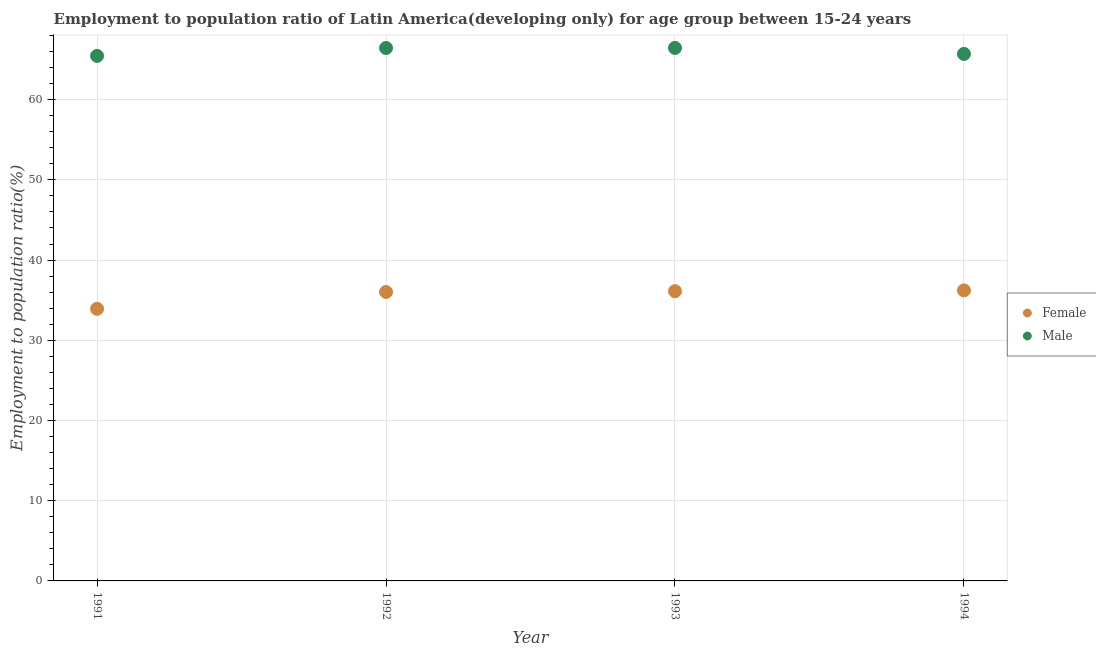How many different coloured dotlines are there?
Offer a terse response. 2. What is the employment to population ratio(male) in 1994?
Offer a very short reply. 65.7. Across all years, what is the maximum employment to population ratio(male)?
Provide a succinct answer. 66.45. Across all years, what is the minimum employment to population ratio(male)?
Keep it short and to the point. 65.45. In which year was the employment to population ratio(female) minimum?
Your answer should be compact. 1991. What is the total employment to population ratio(male) in the graph?
Offer a terse response. 264.04. What is the difference between the employment to population ratio(male) in 1992 and that in 1993?
Provide a succinct answer. -0.01. What is the difference between the employment to population ratio(male) in 1994 and the employment to population ratio(female) in 1992?
Provide a short and direct response. 29.68. What is the average employment to population ratio(female) per year?
Ensure brevity in your answer.  35.57. In the year 1994, what is the difference between the employment to population ratio(male) and employment to population ratio(female)?
Ensure brevity in your answer.  29.48. In how many years, is the employment to population ratio(female) greater than 4 %?
Provide a short and direct response. 4. What is the ratio of the employment to population ratio(male) in 1992 to that in 1994?
Ensure brevity in your answer.  1.01. Is the employment to population ratio(female) in 1993 less than that in 1994?
Offer a very short reply. Yes. Is the difference between the employment to population ratio(male) in 1992 and 1994 greater than the difference between the employment to population ratio(female) in 1992 and 1994?
Provide a succinct answer. Yes. What is the difference between the highest and the second highest employment to population ratio(male)?
Provide a succinct answer. 0.01. What is the difference between the highest and the lowest employment to population ratio(female)?
Offer a terse response. 2.3. Is the sum of the employment to population ratio(male) in 1992 and 1993 greater than the maximum employment to population ratio(female) across all years?
Provide a succinct answer. Yes. Is the employment to population ratio(female) strictly greater than the employment to population ratio(male) over the years?
Offer a very short reply. No. How many dotlines are there?
Your answer should be compact. 2. Are the values on the major ticks of Y-axis written in scientific E-notation?
Your response must be concise. No. Does the graph contain grids?
Your response must be concise. Yes. Where does the legend appear in the graph?
Ensure brevity in your answer.  Center right. What is the title of the graph?
Give a very brief answer. Employment to population ratio of Latin America(developing only) for age group between 15-24 years. Does "Male labor force" appear as one of the legend labels in the graph?
Make the answer very short. No. What is the Employment to population ratio(%) in Female in 1991?
Give a very brief answer. 33.93. What is the Employment to population ratio(%) in Male in 1991?
Your answer should be very brief. 65.45. What is the Employment to population ratio(%) in Female in 1992?
Your response must be concise. 36.02. What is the Employment to population ratio(%) of Male in 1992?
Provide a short and direct response. 66.44. What is the Employment to population ratio(%) in Female in 1993?
Offer a very short reply. 36.12. What is the Employment to population ratio(%) of Male in 1993?
Give a very brief answer. 66.45. What is the Employment to population ratio(%) in Female in 1994?
Make the answer very short. 36.22. What is the Employment to population ratio(%) in Male in 1994?
Give a very brief answer. 65.7. Across all years, what is the maximum Employment to population ratio(%) in Female?
Keep it short and to the point. 36.22. Across all years, what is the maximum Employment to population ratio(%) in Male?
Your answer should be compact. 66.45. Across all years, what is the minimum Employment to population ratio(%) of Female?
Offer a very short reply. 33.93. Across all years, what is the minimum Employment to population ratio(%) in Male?
Provide a short and direct response. 65.45. What is the total Employment to population ratio(%) in Female in the graph?
Your answer should be very brief. 142.29. What is the total Employment to population ratio(%) of Male in the graph?
Offer a terse response. 264.04. What is the difference between the Employment to population ratio(%) of Female in 1991 and that in 1992?
Your answer should be compact. -2.1. What is the difference between the Employment to population ratio(%) in Male in 1991 and that in 1992?
Ensure brevity in your answer.  -0.98. What is the difference between the Employment to population ratio(%) of Female in 1991 and that in 1993?
Keep it short and to the point. -2.19. What is the difference between the Employment to population ratio(%) in Male in 1991 and that in 1993?
Give a very brief answer. -0.99. What is the difference between the Employment to population ratio(%) of Female in 1991 and that in 1994?
Keep it short and to the point. -2.3. What is the difference between the Employment to population ratio(%) in Male in 1991 and that in 1994?
Offer a terse response. -0.25. What is the difference between the Employment to population ratio(%) of Female in 1992 and that in 1993?
Your answer should be very brief. -0.09. What is the difference between the Employment to population ratio(%) of Male in 1992 and that in 1993?
Offer a very short reply. -0.01. What is the difference between the Employment to population ratio(%) of Female in 1992 and that in 1994?
Offer a very short reply. -0.2. What is the difference between the Employment to population ratio(%) of Male in 1992 and that in 1994?
Offer a terse response. 0.74. What is the difference between the Employment to population ratio(%) of Female in 1993 and that in 1994?
Your answer should be compact. -0.1. What is the difference between the Employment to population ratio(%) of Male in 1993 and that in 1994?
Provide a succinct answer. 0.75. What is the difference between the Employment to population ratio(%) of Female in 1991 and the Employment to population ratio(%) of Male in 1992?
Make the answer very short. -32.51. What is the difference between the Employment to population ratio(%) of Female in 1991 and the Employment to population ratio(%) of Male in 1993?
Offer a terse response. -32.52. What is the difference between the Employment to population ratio(%) of Female in 1991 and the Employment to population ratio(%) of Male in 1994?
Provide a short and direct response. -31.78. What is the difference between the Employment to population ratio(%) in Female in 1992 and the Employment to population ratio(%) in Male in 1993?
Provide a succinct answer. -30.42. What is the difference between the Employment to population ratio(%) in Female in 1992 and the Employment to population ratio(%) in Male in 1994?
Keep it short and to the point. -29.68. What is the difference between the Employment to population ratio(%) of Female in 1993 and the Employment to population ratio(%) of Male in 1994?
Keep it short and to the point. -29.58. What is the average Employment to population ratio(%) of Female per year?
Your answer should be very brief. 35.57. What is the average Employment to population ratio(%) in Male per year?
Your response must be concise. 66.01. In the year 1991, what is the difference between the Employment to population ratio(%) in Female and Employment to population ratio(%) in Male?
Provide a succinct answer. -31.53. In the year 1992, what is the difference between the Employment to population ratio(%) in Female and Employment to population ratio(%) in Male?
Ensure brevity in your answer.  -30.41. In the year 1993, what is the difference between the Employment to population ratio(%) of Female and Employment to population ratio(%) of Male?
Offer a very short reply. -30.33. In the year 1994, what is the difference between the Employment to population ratio(%) in Female and Employment to population ratio(%) in Male?
Make the answer very short. -29.48. What is the ratio of the Employment to population ratio(%) of Female in 1991 to that in 1992?
Your response must be concise. 0.94. What is the ratio of the Employment to population ratio(%) in Male in 1991 to that in 1992?
Offer a very short reply. 0.99. What is the ratio of the Employment to population ratio(%) of Female in 1991 to that in 1993?
Your answer should be very brief. 0.94. What is the ratio of the Employment to population ratio(%) in Male in 1991 to that in 1993?
Your answer should be compact. 0.98. What is the ratio of the Employment to population ratio(%) in Female in 1991 to that in 1994?
Your answer should be very brief. 0.94. What is the ratio of the Employment to population ratio(%) in Male in 1991 to that in 1994?
Make the answer very short. 1. What is the ratio of the Employment to population ratio(%) in Female in 1992 to that in 1994?
Provide a succinct answer. 0.99. What is the ratio of the Employment to population ratio(%) in Male in 1992 to that in 1994?
Give a very brief answer. 1.01. What is the ratio of the Employment to population ratio(%) of Male in 1993 to that in 1994?
Keep it short and to the point. 1.01. What is the difference between the highest and the second highest Employment to population ratio(%) in Female?
Ensure brevity in your answer.  0.1. What is the difference between the highest and the second highest Employment to population ratio(%) in Male?
Offer a terse response. 0.01. What is the difference between the highest and the lowest Employment to population ratio(%) in Female?
Provide a succinct answer. 2.3. What is the difference between the highest and the lowest Employment to population ratio(%) of Male?
Your answer should be compact. 0.99. 